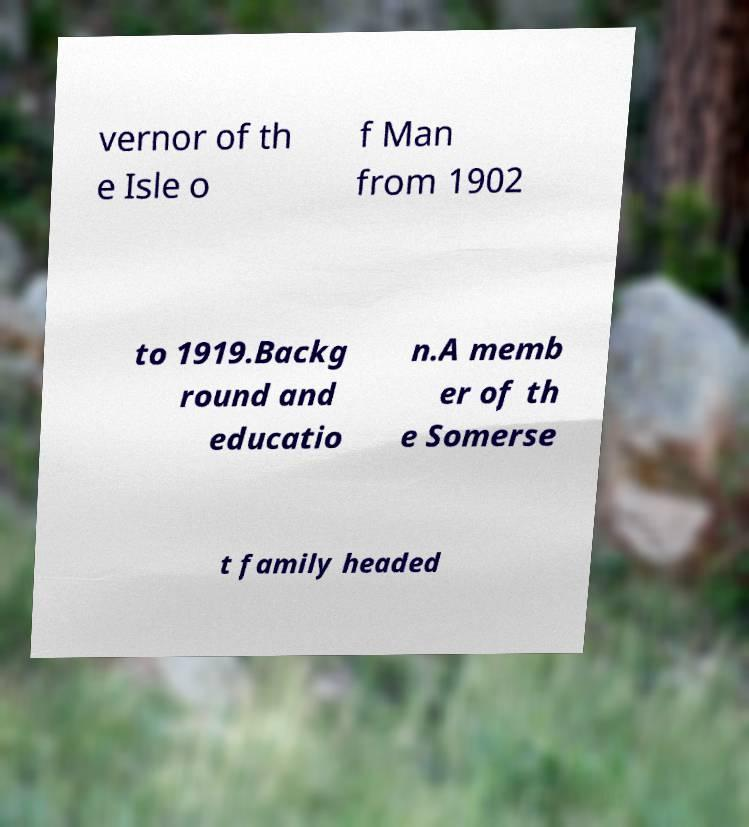Can you accurately transcribe the text from the provided image for me? vernor of th e Isle o f Man from 1902 to 1919.Backg round and educatio n.A memb er of th e Somerse t family headed 